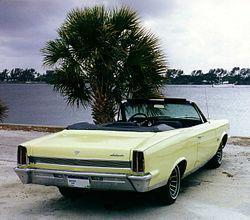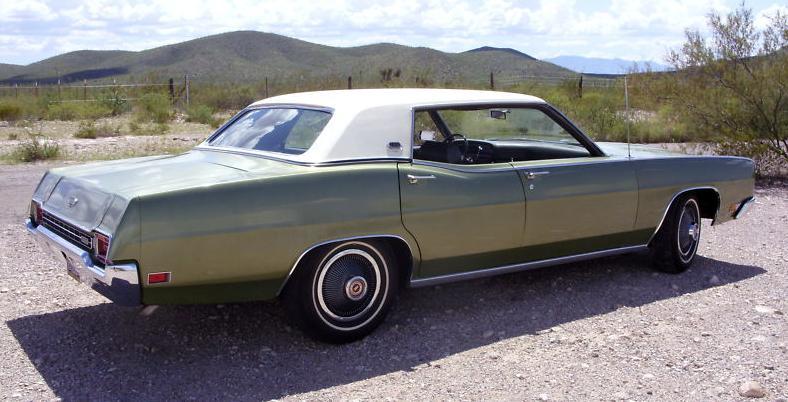The first image is the image on the left, the second image is the image on the right. Analyze the images presented: Is the assertion "Right and left images each contain a convertible in side view with its top partly raised." valid? Answer yes or no. No. The first image is the image on the left, the second image is the image on the right. Given the left and right images, does the statement "The right image contains at least one red sports car." hold true? Answer yes or no. No. 